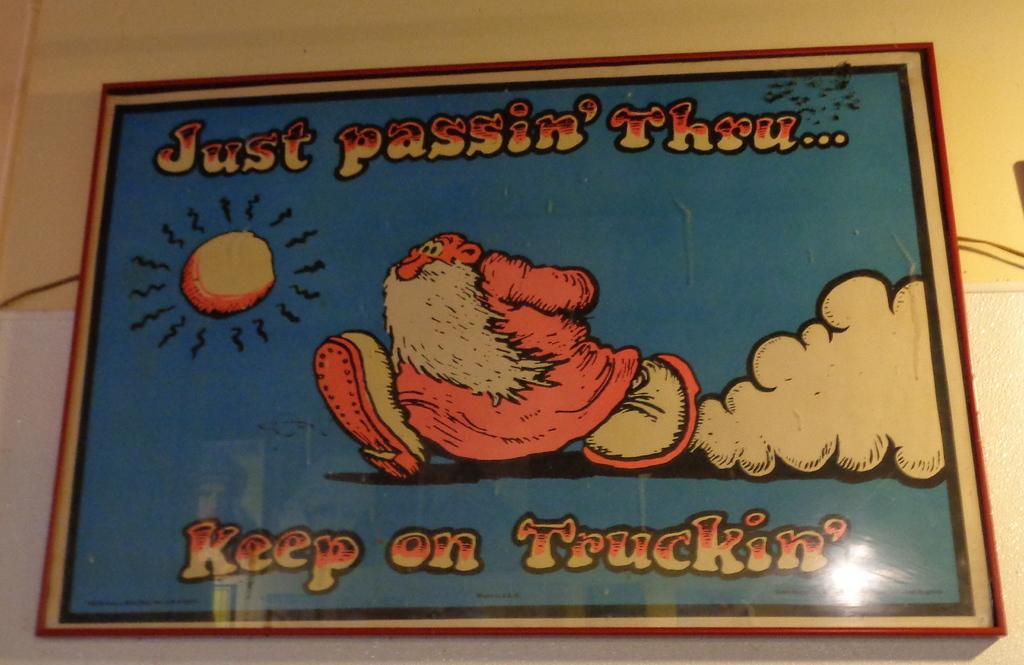What is the main subject in the center of the image? There is a frame in the center of the image. What is inside the frame? The frame contains text and a diagram. How is the frame positioned in the image? The frame is attached to the wall. What is the price of the room depicted in the diagram within the frame? There is no room depicted in the diagram within the frame, nor is there any information about prices. 